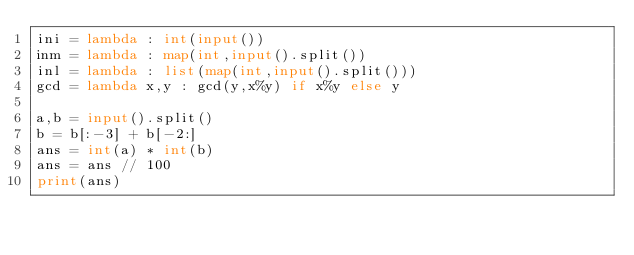Convert code to text. <code><loc_0><loc_0><loc_500><loc_500><_Python_>ini = lambda : int(input())
inm = lambda : map(int,input().split())
inl = lambda : list(map(int,input().split()))
gcd = lambda x,y : gcd(y,x%y) if x%y else y

a,b = input().split()
b = b[:-3] + b[-2:]
ans = int(a) * int(b)
ans = ans // 100
print(ans)
</code> 